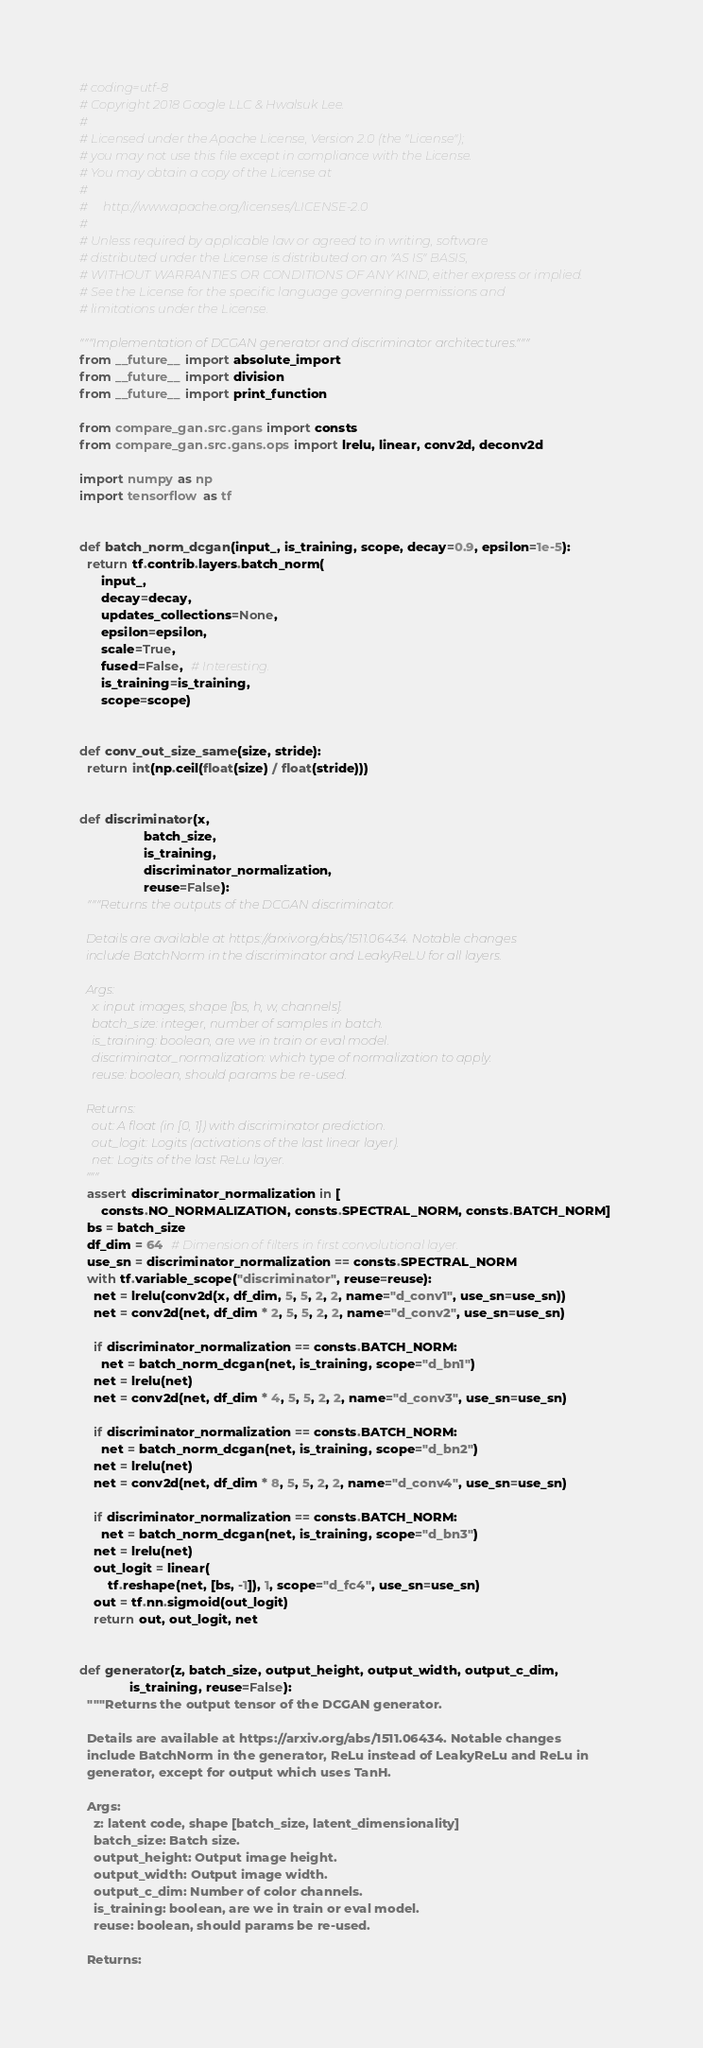<code> <loc_0><loc_0><loc_500><loc_500><_Python_># coding=utf-8
# Copyright 2018 Google LLC & Hwalsuk Lee.
#
# Licensed under the Apache License, Version 2.0 (the "License");
# you may not use this file except in compliance with the License.
# You may obtain a copy of the License at
#
#     http://www.apache.org/licenses/LICENSE-2.0
#
# Unless required by applicable law or agreed to in writing, software
# distributed under the License is distributed on an "AS IS" BASIS,
# WITHOUT WARRANTIES OR CONDITIONS OF ANY KIND, either express or implied.
# See the License for the specific language governing permissions and
# limitations under the License.

"""Implementation of DCGAN generator and discriminator architectures."""
from __future__ import absolute_import
from __future__ import division
from __future__ import print_function

from compare_gan.src.gans import consts
from compare_gan.src.gans.ops import lrelu, linear, conv2d, deconv2d

import numpy as np
import tensorflow as tf


def batch_norm_dcgan(input_, is_training, scope, decay=0.9, epsilon=1e-5):
  return tf.contrib.layers.batch_norm(
      input_,
      decay=decay,
      updates_collections=None,
      epsilon=epsilon,
      scale=True,
      fused=False,  # Interesting.
      is_training=is_training,
      scope=scope)


def conv_out_size_same(size, stride):
  return int(np.ceil(float(size) / float(stride)))


def discriminator(x,
                  batch_size,
                  is_training,
                  discriminator_normalization,
                  reuse=False):
  """Returns the outputs of the DCGAN discriminator.

  Details are available at https://arxiv.org/abs/1511.06434. Notable changes
  include BatchNorm in the discriminator and LeakyReLU for all layers.

  Args:
    x: input images, shape [bs, h, w, channels].
    batch_size: integer, number of samples in batch.
    is_training: boolean, are we in train or eval model.
    discriminator_normalization: which type of normalization to apply.
    reuse: boolean, should params be re-used.

  Returns:
    out: A float (in [0, 1]) with discriminator prediction.
    out_logit: Logits (activations of the last linear layer).
    net: Logits of the last ReLu layer.
  """
  assert discriminator_normalization in [
      consts.NO_NORMALIZATION, consts.SPECTRAL_NORM, consts.BATCH_NORM]
  bs = batch_size
  df_dim = 64  # Dimension of filters in first convolutional layer.
  use_sn = discriminator_normalization == consts.SPECTRAL_NORM
  with tf.variable_scope("discriminator", reuse=reuse):
    net = lrelu(conv2d(x, df_dim, 5, 5, 2, 2, name="d_conv1", use_sn=use_sn))
    net = conv2d(net, df_dim * 2, 5, 5, 2, 2, name="d_conv2", use_sn=use_sn)

    if discriminator_normalization == consts.BATCH_NORM:
      net = batch_norm_dcgan(net, is_training, scope="d_bn1")
    net = lrelu(net)
    net = conv2d(net, df_dim * 4, 5, 5, 2, 2, name="d_conv3", use_sn=use_sn)

    if discriminator_normalization == consts.BATCH_NORM:
      net = batch_norm_dcgan(net, is_training, scope="d_bn2")
    net = lrelu(net)
    net = conv2d(net, df_dim * 8, 5, 5, 2, 2, name="d_conv4", use_sn=use_sn)

    if discriminator_normalization == consts.BATCH_NORM:
      net = batch_norm_dcgan(net, is_training, scope="d_bn3")
    net = lrelu(net)
    out_logit = linear(
        tf.reshape(net, [bs, -1]), 1, scope="d_fc4", use_sn=use_sn)
    out = tf.nn.sigmoid(out_logit)
    return out, out_logit, net


def generator(z, batch_size, output_height, output_width, output_c_dim,
              is_training, reuse=False):
  """Returns the output tensor of the DCGAN generator.

  Details are available at https://arxiv.org/abs/1511.06434. Notable changes
  include BatchNorm in the generator, ReLu instead of LeakyReLu and ReLu in
  generator, except for output which uses TanH.

  Args:
    z: latent code, shape [batch_size, latent_dimensionality]
    batch_size: Batch size.
    output_height: Output image height.
    output_width: Output image width.
    output_c_dim: Number of color channels.
    is_training: boolean, are we in train or eval model.
    reuse: boolean, should params be re-used.

  Returns:</code> 